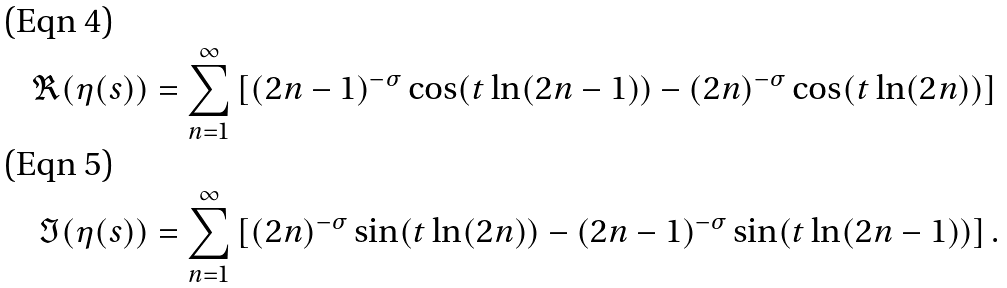Convert formula to latex. <formula><loc_0><loc_0><loc_500><loc_500>\Re ( \eta ( s ) ) & = \sum _ { n = 1 } ^ { \infty } \left [ ( 2 n - 1 ) ^ { - \sigma } \cos ( t \ln ( 2 n - 1 ) ) - ( 2 n ) ^ { - \sigma } \cos ( t \ln ( 2 n ) ) \right ] \\ \Im ( \eta ( s ) ) & = \sum _ { n = 1 } ^ { \infty } \left [ ( 2 n ) ^ { - \sigma } \sin ( t \ln ( 2 n ) ) - ( 2 n - 1 ) ^ { - \sigma } \sin ( t \ln ( 2 n - 1 ) ) \right ] .</formula> 